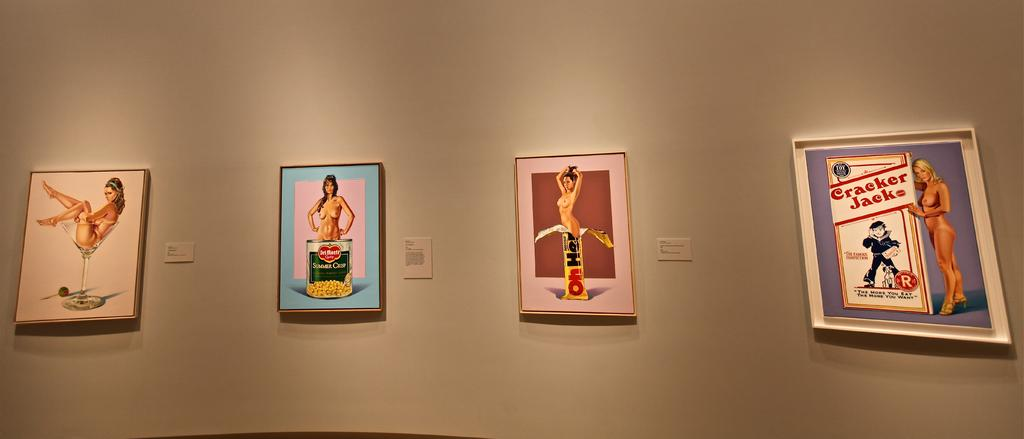<image>
Render a clear and concise summary of the photo. Products displayed in museum artwork include Cracker Jacks, Oh Henry candy, and Del Monte canned vegetables. 